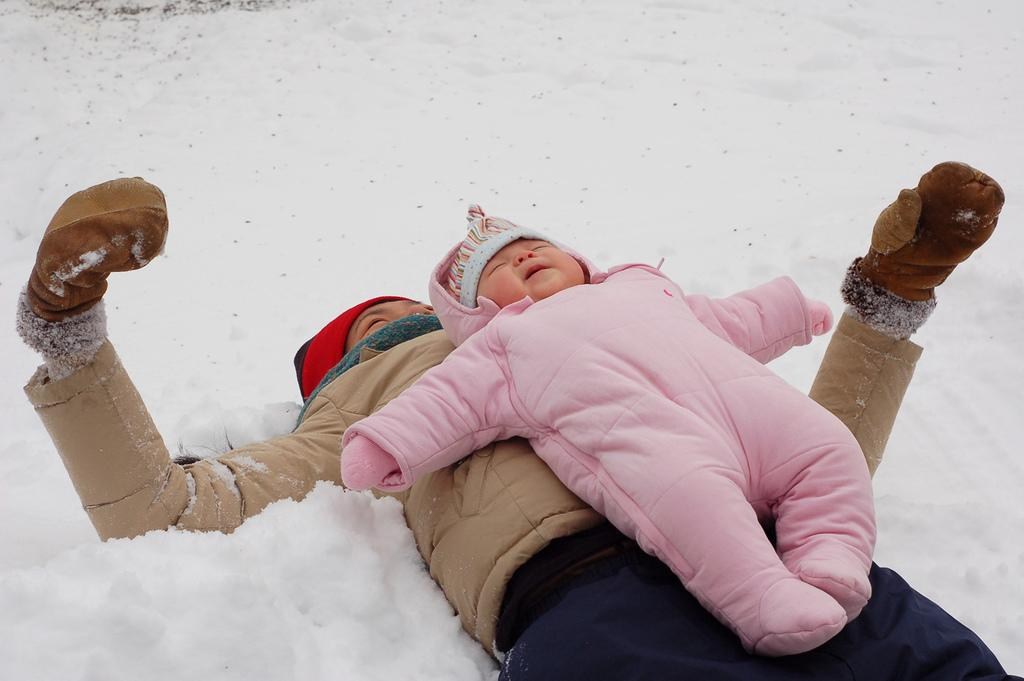What is the main subject of the image? There is a baby in the image. What is the baby's position in the image? The baby is laying on a person. Where are the baby and person located in the image? The baby and person are on the ground. What is the ground covered with in the image? The ground is covered with snow. What shapes can be seen in the sky in the image? There are no shapes visible in the sky in the image, as the sky is not mentioned in the provided facts. 